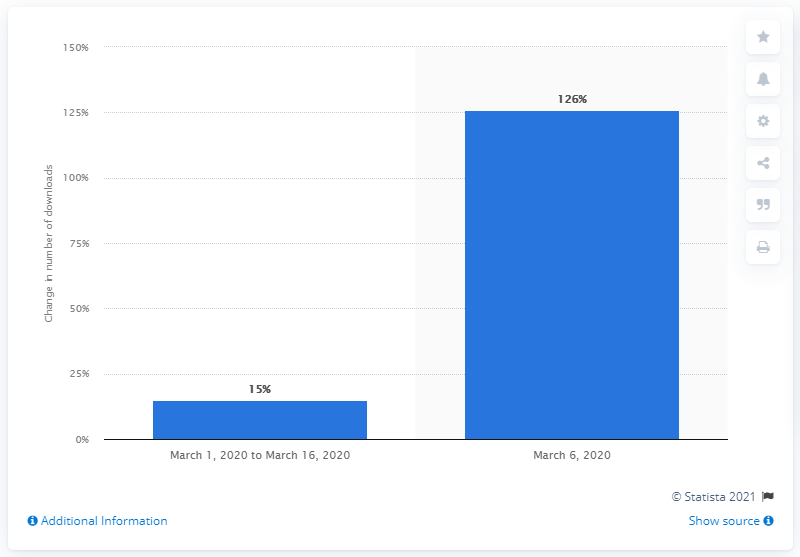Specify some key components in this picture. On March 6, 2020, the number of downloads of delivery apps in Brazil increased by 126 compared to the previous day. On March 6, 2020, downloads of delivery apps increased by 126 percent compared to March 2019. 